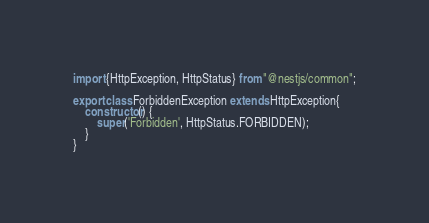Convert code to text. <code><loc_0><loc_0><loc_500><loc_500><_TypeScript_>import {HttpException, HttpStatus} from "@nestjs/common";

export class ForbiddenException extends HttpException{
    constructor() {
        super('Forbidden', HttpStatus.FORBIDDEN);
    }
}</code> 